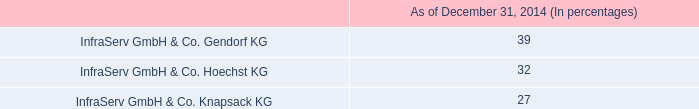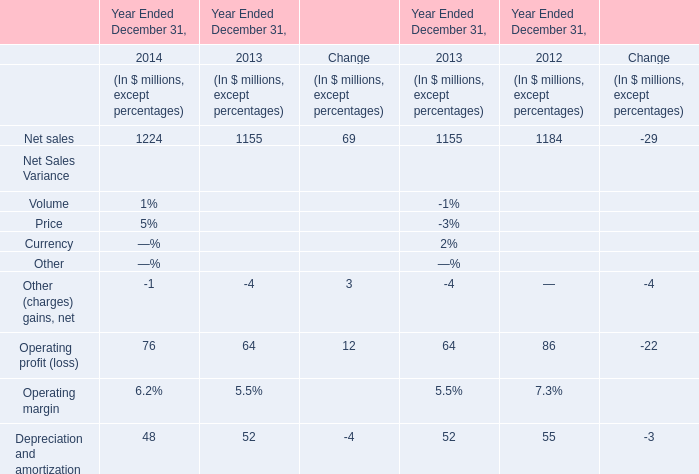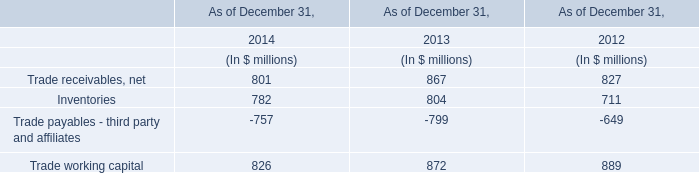what is the ratio of the cash dividend to the research and development in 2014 
Computations: (115 / 86)
Answer: 1.33721. 